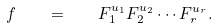<formula> <loc_0><loc_0><loc_500><loc_500>f \quad = \quad F _ { 1 } ^ { u _ { 1 } } F _ { 2 } ^ { u _ { 2 } } \cdots F _ { r } ^ { u _ { r } } .</formula> 